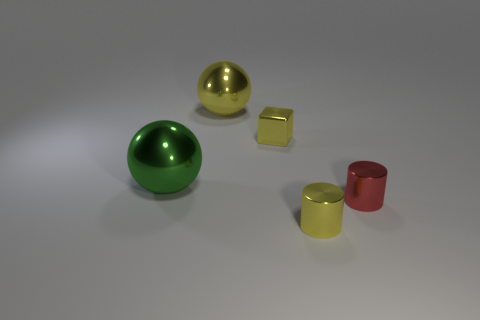There is a cylinder behind the small yellow metal object that is in front of the shiny block; what size is it?
Provide a short and direct response. Small. How many things are large brown cubes or small shiny cylinders?
Make the answer very short. 2. Are there any metallic spheres of the same color as the block?
Offer a very short reply. Yes. Are there fewer big red matte cylinders than yellow metal blocks?
Give a very brief answer. Yes. How many things are either small yellow cylinders or balls that are behind the metallic block?
Offer a very short reply. 2. Are there any big yellow things made of the same material as the big yellow ball?
Make the answer very short. No. There is another sphere that is the same size as the green ball; what material is it?
Your answer should be compact. Metal. The big sphere behind the tiny yellow metal thing behind the tiny yellow cylinder is made of what material?
Ensure brevity in your answer.  Metal. Is the shape of the object that is in front of the red metallic thing the same as  the large yellow object?
Your answer should be very brief. No. There is a ball that is made of the same material as the large green thing; what is its color?
Your response must be concise. Yellow. 